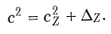Convert formula to latex. <formula><loc_0><loc_0><loc_500><loc_500>c ^ { 2 } = c _ { Z } ^ { 2 } + \Delta _ { Z } .</formula> 